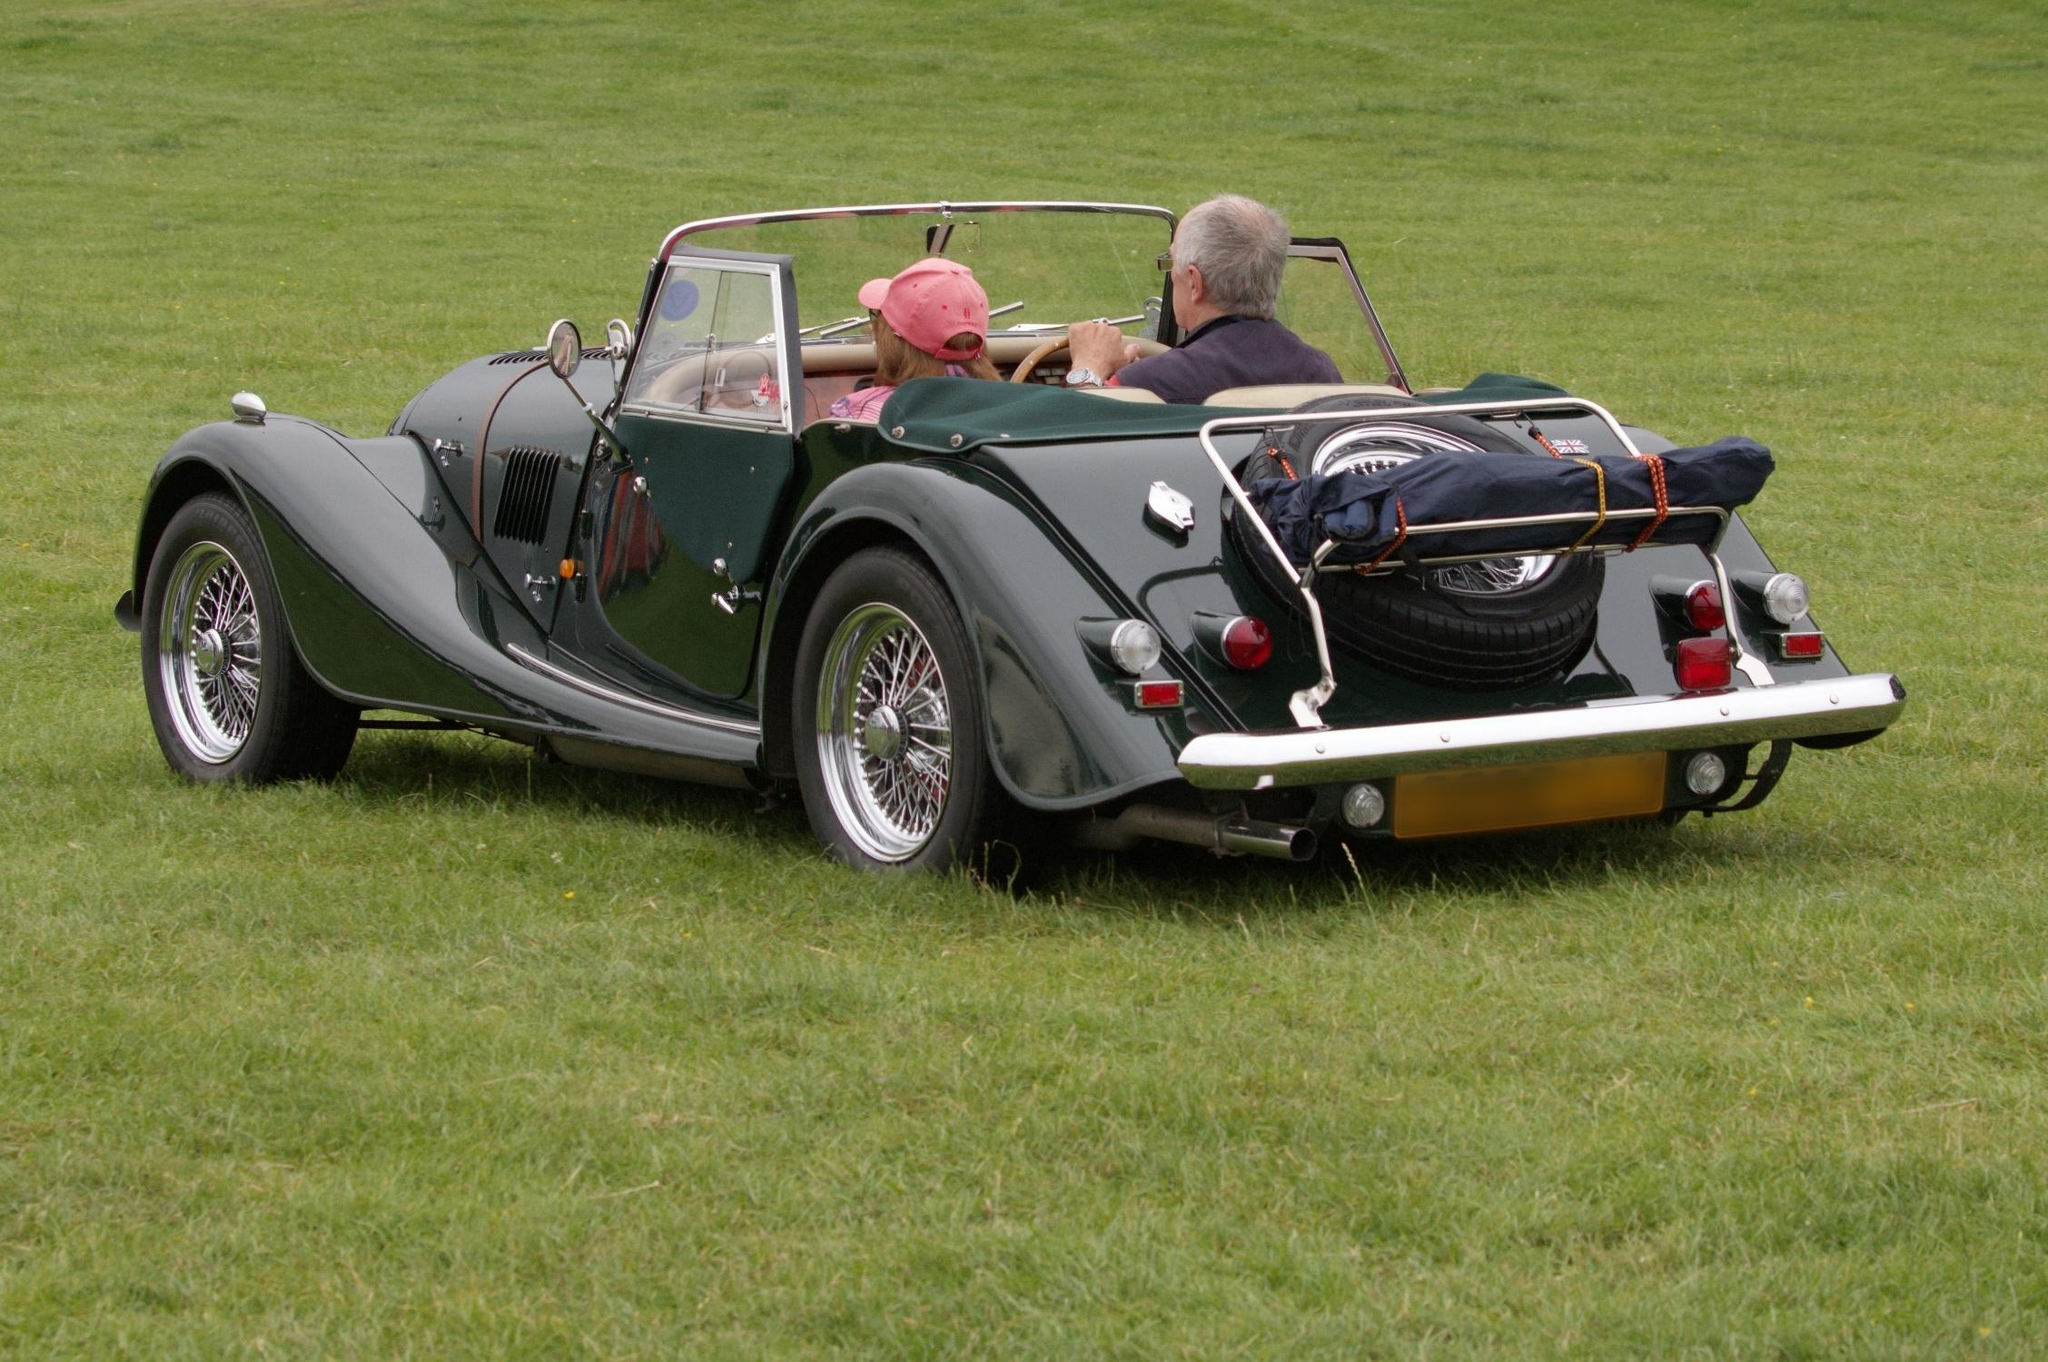If this scene were a painting, what emotions and themes might it evoke? As a painting, this scene would likely evoke emotions of nostalgia, tranquility, and a love for simpler times. The depiction of the vintage car, meticulously crafted and gleaming, would symbolize an admiration for history and an appreciation for classic beauty. The open grassy field would enhance the sense of freedom and peace, hinting at endless journeys and leisurely days. Themes of adventure, timelessness, and the harmonious blend of man and machine could be beautifully explored. The individuals in the car might symbolize companionship and shared experiences, making the viewer ponder about the stories they might be creating together. Do you think this image could tell a story of a reunion? Can you describe it in detail? Imagine this scene as the culmination of a heartfelt reunion. After many years apart, two old friends or perhaps siblings decided to rekindle their bond through a journey in a car that carried with it memories of their youth. The car, once a symbol of their adventures and dreams, has been lovingly restored, much like their friendship. They meet on this expansive field, a place from their past where they once dreamed of the future. Now older and wiser, they revisit their tales, sharing laughter and heartfelt moments, reminiscing about their escapades and the paths life has taken them on. This journey is symbolic, not just a physical drive but a drive down memory lane, embracing where they began and the countless stories that lie ahead. What would happen if the car suddenly transported them to the past? Be as detailed and creative as you can! In a flash of light, the vintage car becomes a time machine, whirling the two passengers back to the roaring 1920s. They find themselves in a vibrant cityscape, the streets bustling with flapper-clad dancers, jazz musicians, and the hum of Model T Fords. They're dressed in period attire, blending into a world where speakeasies operate in secrecy and the air is filled with the scent of change and rebellion. Navigating through this era, they witness the exuberance and challenges of Prohibition America, attending lavish parties, and meeting iconic figures like F. Scott Fitzgerald and Duke Ellington. Each drive down a cobblestone street or a moonlit avenue reveals a new layer of history, from the rise of the automobile culture to the silent cries of the Great Depression lurking just around the corner. Their car, a beacon of anachronism, attracts curiosity and admiration, leading them to clandestine corners where the hidden histories of the era come alive. They realize that their journey isn't just about witnessing the past but understanding the resilience, creativity, and spirit of those who lived it. As they navigate through this time, they gather stories, wisdom, and experiences, ultimately finding their way back, forever changed by their extraordinary voyage. 